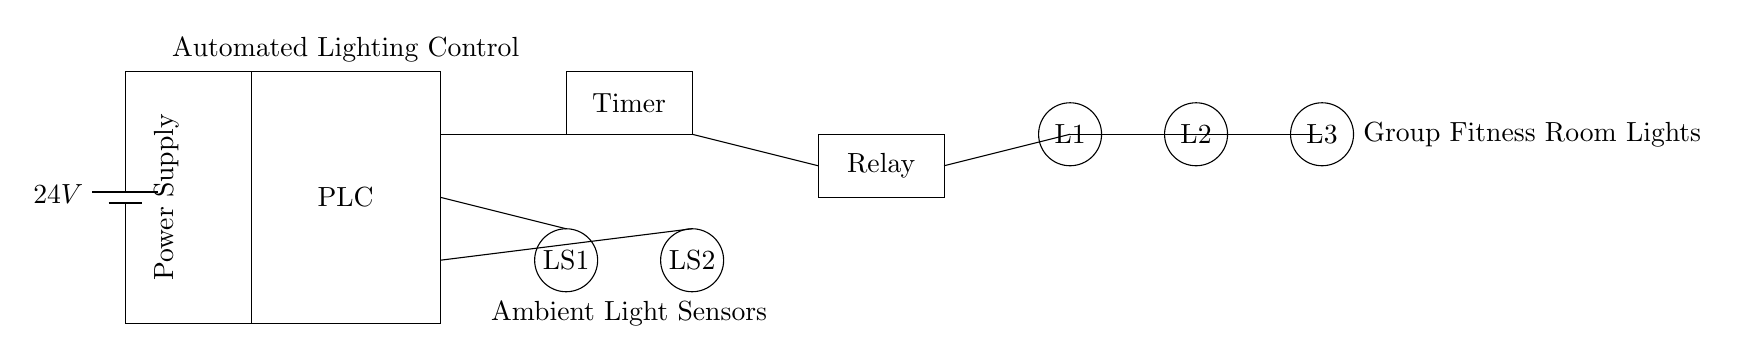What is the voltage of this circuit? The voltage is 24 volts, which is indicated by the battery symbol in the circuit diagram.
Answer: 24 volts What components are used for ambient light detection? The components used for ambient light detection are two light sensors labeled as LS1 and LS2, which are shown as circles in the diagram.
Answer: Light sensors What is the purpose of the relay in this circuit? The relay is used to control the power to the lights based on signals from the PLC and timer, enabling automated lighting control for the fitness classes.
Answer: Control lights How many lights are connected in this circuit? There are three lights labeled L1, L2, and L3, which are represented as circles in the circuit diagram.
Answer: Three lights What triggers the activation of the lights? The activation of the lights is triggered by input from the PLC and timer, which processes the information from the ambient light sensors to determine when to turn on or off the lights.
Answer: PLC and Timer What is the function of the timer in this circuit? The timer controls the duration and timing of when the lights are turned on or off, allowing for automation based on class schedules.
Answer: Control duration 